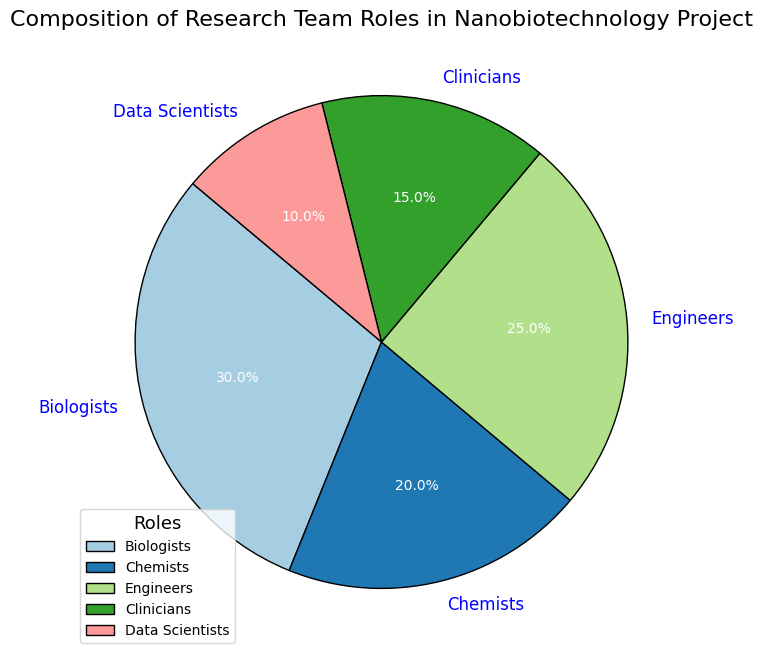Which role has the largest percentage in the research team? The largest section in the pie chart is colored blue and represents Biologists with a percentage of 30%.
Answer: Biologists Which role has the smallest percentage in the research team? The smallest section in the pie chart is colored in a light shade and represents Data Scientists with a percentage of 10%.
Answer: Data Scientists What is the combined percentage of Engineers and Clinicians in the research team? Engineers represent 25% and Clinicians represent 15%. Adding these percentages together gives 25% + 15% = 40%.
Answer: 40% Is the percentage of Biologists greater than the percentage of Chemists and Clinicians combined? Biologists have 30%. Chemists and Clinicians together have 20% + 15% = 35%. So, 30% is less than 35%.
Answer: No What is the difference in percentage between Biologists and Engineers? Biologists have 30% and Engineers have 25%. The difference is 30% - 25% = 5%.
Answer: 5% Which two roles combined account for exactly half of the research team? Biologists have 30% and Data Scientists have 10%. Adding these two gives us 30% + 10% = 40%, which is not half. By checking other combinations, we find that Engineers (25%) and Clinicians (15%) add up to 25% + 15% = 40%. However, Chemists (20%) and Engineers (25%) give 20% + 25% = 45%. There is no exact pair that sums up to 50%.
Answer: None How much more is the percentage of Biologists than the percentage of Data Scientists? Biologists have 30% while Data Scientists have 10%. The difference is 30% - 10% = 20%.
Answer: 20% If you were to reassign 10% of the team from Biologists to Data Scientists, how would the new percentages for these roles look? Original: Biologists 30%, Data Scientists 10%. After reassigning 10%: Biologists 30% - 10% = 20%, Data Scientists 10% + 10% = 20%.
Answer: Biologists: 20%, Data Scientists: 20% Among Chemists and Engineers, which group occupies more of the research team, and by what percentage? Engineers have 25% while Chemists have 20%. The difference is 25% - 20% = 5%.
Answer: Engineers, by 5% What is the average percentage of all roles in the research team? The sum of all percentages is 30% + 20% + 25% + 15% + 10% = 100%. There are 5 roles, so the average percentage is 100% / 5 = 20%.
Answer: 20% 